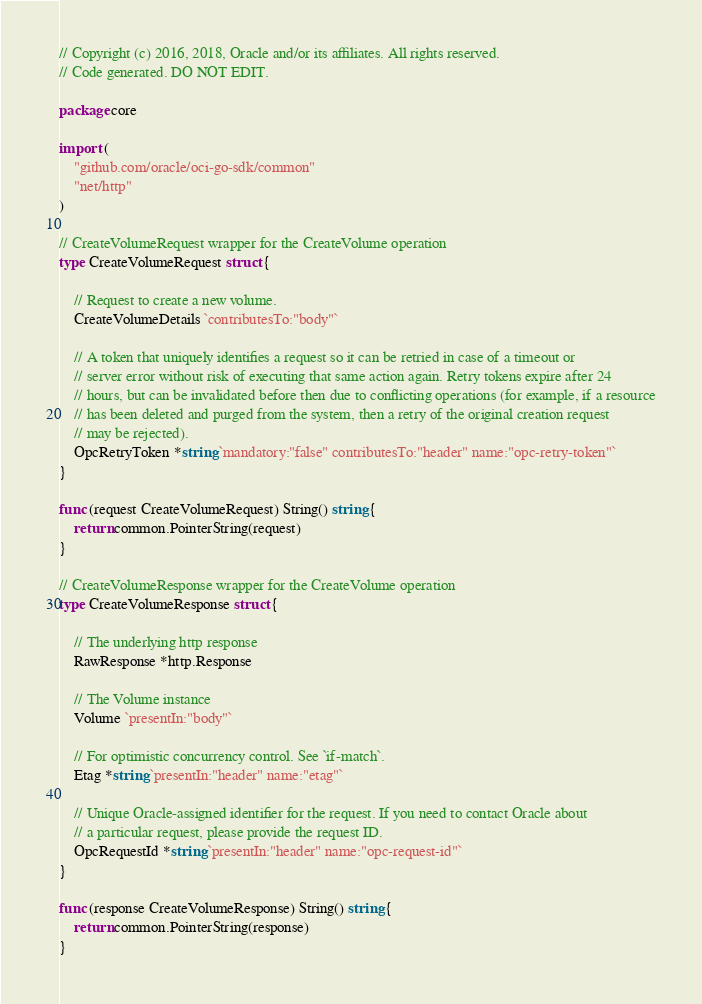<code> <loc_0><loc_0><loc_500><loc_500><_Go_>// Copyright (c) 2016, 2018, Oracle and/or its affiliates. All rights reserved.
// Code generated. DO NOT EDIT.

package core

import (
	"github.com/oracle/oci-go-sdk/common"
	"net/http"
)

// CreateVolumeRequest wrapper for the CreateVolume operation
type CreateVolumeRequest struct {

	// Request to create a new volume.
	CreateVolumeDetails `contributesTo:"body"`

	// A token that uniquely identifies a request so it can be retried in case of a timeout or
	// server error without risk of executing that same action again. Retry tokens expire after 24
	// hours, but can be invalidated before then due to conflicting operations (for example, if a resource
	// has been deleted and purged from the system, then a retry of the original creation request
	// may be rejected).
	OpcRetryToken *string `mandatory:"false" contributesTo:"header" name:"opc-retry-token"`
}

func (request CreateVolumeRequest) String() string {
	return common.PointerString(request)
}

// CreateVolumeResponse wrapper for the CreateVolume operation
type CreateVolumeResponse struct {

	// The underlying http response
	RawResponse *http.Response

	// The Volume instance
	Volume `presentIn:"body"`

	// For optimistic concurrency control. See `if-match`.
	Etag *string `presentIn:"header" name:"etag"`

	// Unique Oracle-assigned identifier for the request. If you need to contact Oracle about
	// a particular request, please provide the request ID.
	OpcRequestId *string `presentIn:"header" name:"opc-request-id"`
}

func (response CreateVolumeResponse) String() string {
	return common.PointerString(response)
}
</code> 